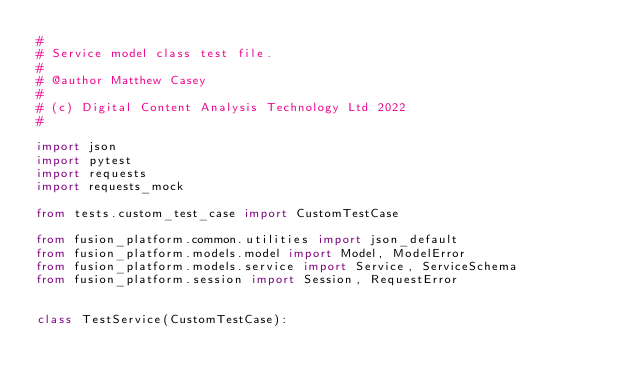Convert code to text. <code><loc_0><loc_0><loc_500><loc_500><_Python_>#
# Service model class test file.
#
# @author Matthew Casey
#
# (c) Digital Content Analysis Technology Ltd 2022
#

import json
import pytest
import requests
import requests_mock

from tests.custom_test_case import CustomTestCase

from fusion_platform.common.utilities import json_default
from fusion_platform.models.model import Model, ModelError
from fusion_platform.models.service import Service, ServiceSchema
from fusion_platform.session import Session, RequestError


class TestService(CustomTestCase):</code> 